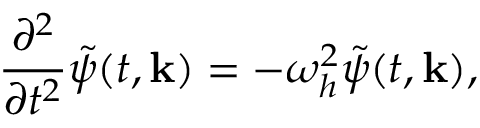<formula> <loc_0><loc_0><loc_500><loc_500>\frac { \partial ^ { 2 } } { \partial t ^ { 2 } } \tilde { \psi } ( t , { k } ) = - \omega _ { h } ^ { 2 } \tilde { \psi } ( t , { k } ) ,</formula> 